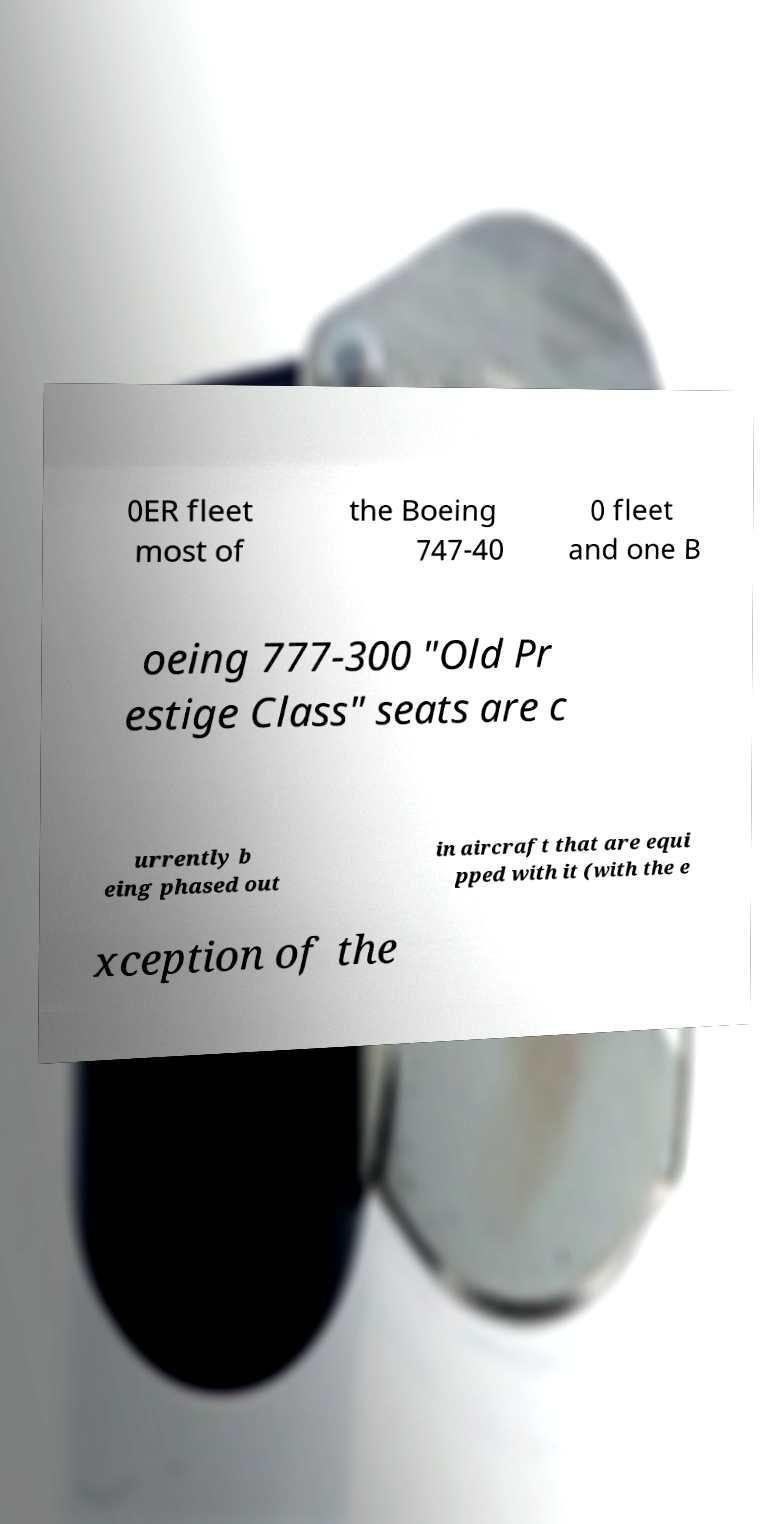Can you accurately transcribe the text from the provided image for me? 0ER fleet most of the Boeing 747-40 0 fleet and one B oeing 777-300 "Old Pr estige Class" seats are c urrently b eing phased out in aircraft that are equi pped with it (with the e xception of the 